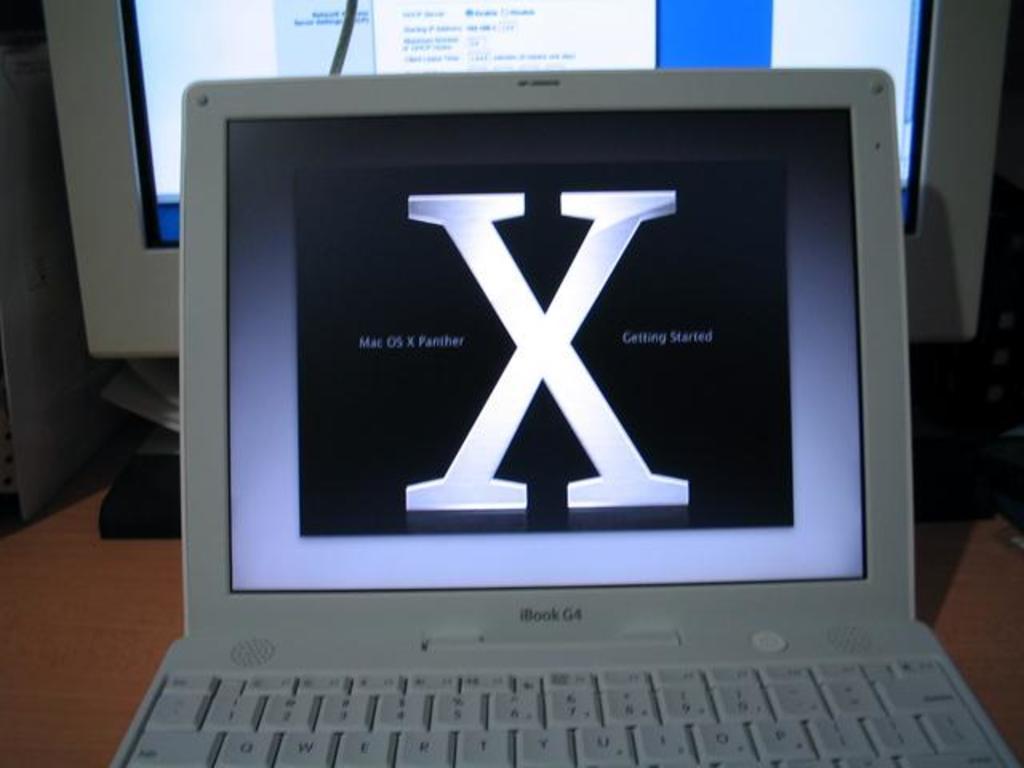What big letter is displayed on the laptop screen?
Your answer should be compact. X. What is computer brand?
Make the answer very short. Ibook. 